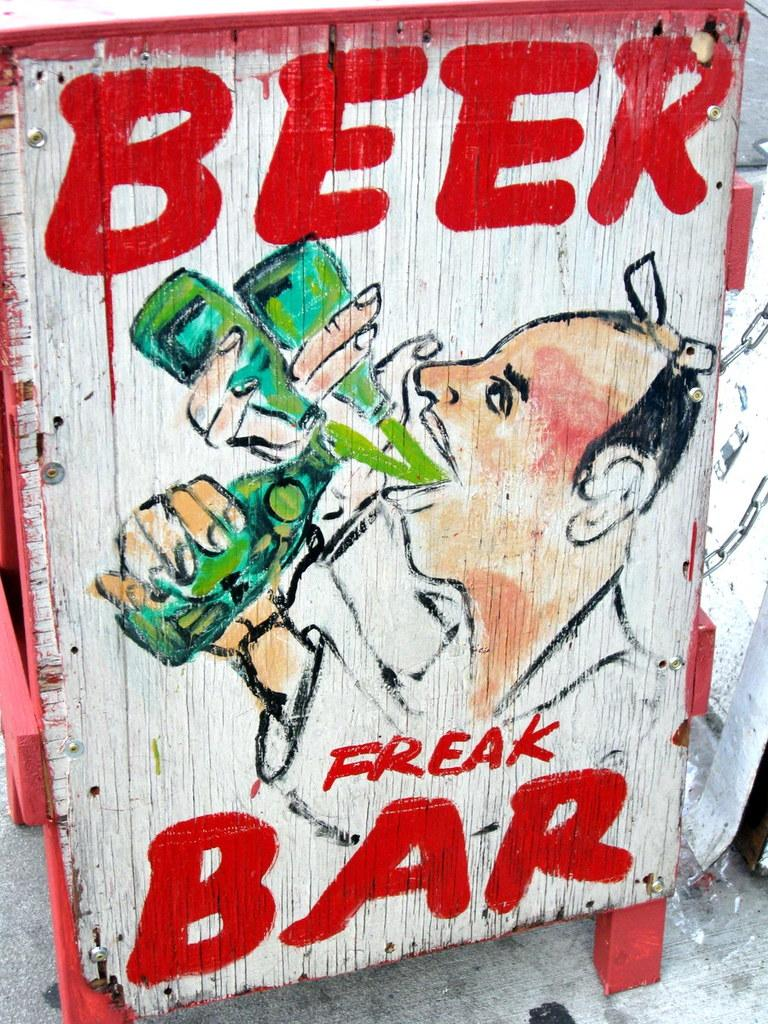What object is made of wood in the image? There is a wooden box in the image. Who is present in the image? There is a man in the image. What is the man doing in the image? The man is drinking beer. What else can be seen in the image besides the man and the wooden box? There is text in the image. What invention does the man regret in the image? There is no indication of regret or any invention in the image. 